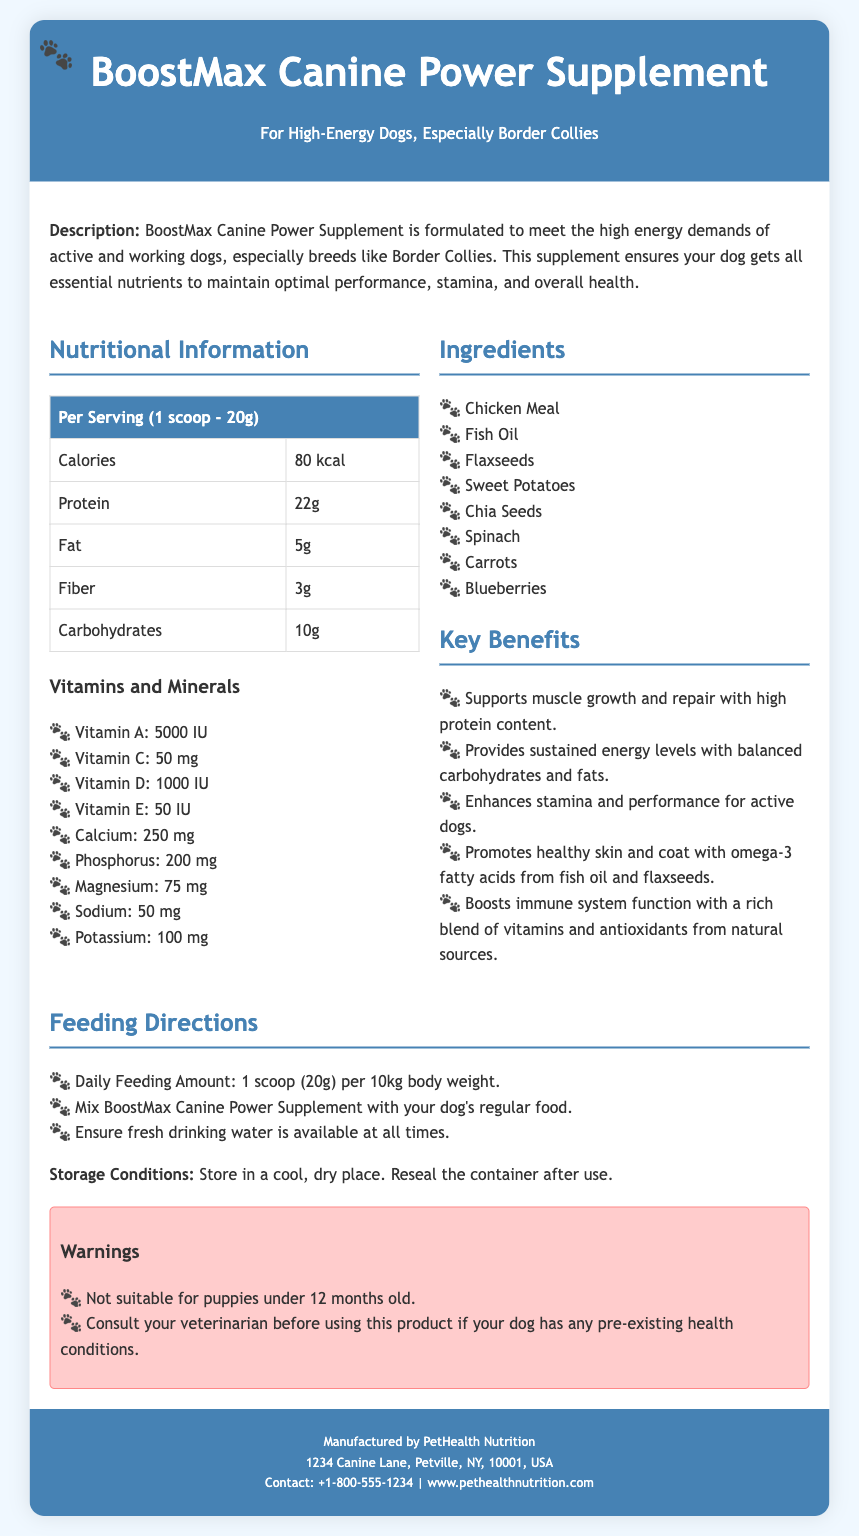What is the name of the supplement? The name of the supplement is BoostMax Canine Power Supplement, as stated in the header section.
Answer: BoostMax Canine Power Supplement What is the target dog breed mentioned? The document specifies that the supplement is formulated for high-energy dogs, especially Border Collies.
Answer: Border Collies How many calories are in one serving? The nutrition table shows that one serving (1 scoop - 20g) contains 80 kcal.
Answer: 80 kcal What is the protein content per serving? The nutrition information states that the protein content per serving is 22g.
Answer: 22g What is the recommended daily feeding amount? The feeding directions indicate that the daily feeding amount is 1 scoop (20g) per 10kg body weight.
Answer: 1 scoop (20g) per 10kg Which ingredient is used for healthy skin and coat? The key benefits section mentions omega-3 fatty acids from fish oil and flaxseeds promote healthy skin and coat.
Answer: Fish oil and flaxseeds What should you do before using this product if your dog has health conditions? The warnings section advises consulting your veterinarian before using the product if your dog has any pre-existing health conditions.
Answer: Consult your veterinarian What is the storage condition mentioned? The document specifies to store the supplement in a cool, dry place and reseal the container after use.
Answer: Cool, dry place What is the purpose of the product? The description states that the supplement ensures your dog gets all essential nutrients to maintain optimal performance, stamina, and overall health.
Answer: To maintain optimal performance, stamina, and overall health 